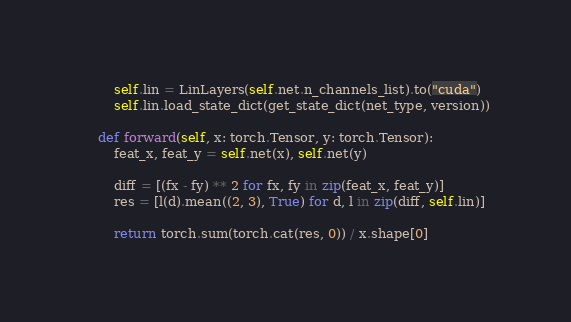<code> <loc_0><loc_0><loc_500><loc_500><_Python_>        self.lin = LinLayers(self.net.n_channels_list).to("cuda")
        self.lin.load_state_dict(get_state_dict(net_type, version))

    def forward(self, x: torch.Tensor, y: torch.Tensor):
        feat_x, feat_y = self.net(x), self.net(y)

        diff = [(fx - fy) ** 2 for fx, fy in zip(feat_x, feat_y)]
        res = [l(d).mean((2, 3), True) for d, l in zip(diff, self.lin)]

        return torch.sum(torch.cat(res, 0)) / x.shape[0]
</code> 